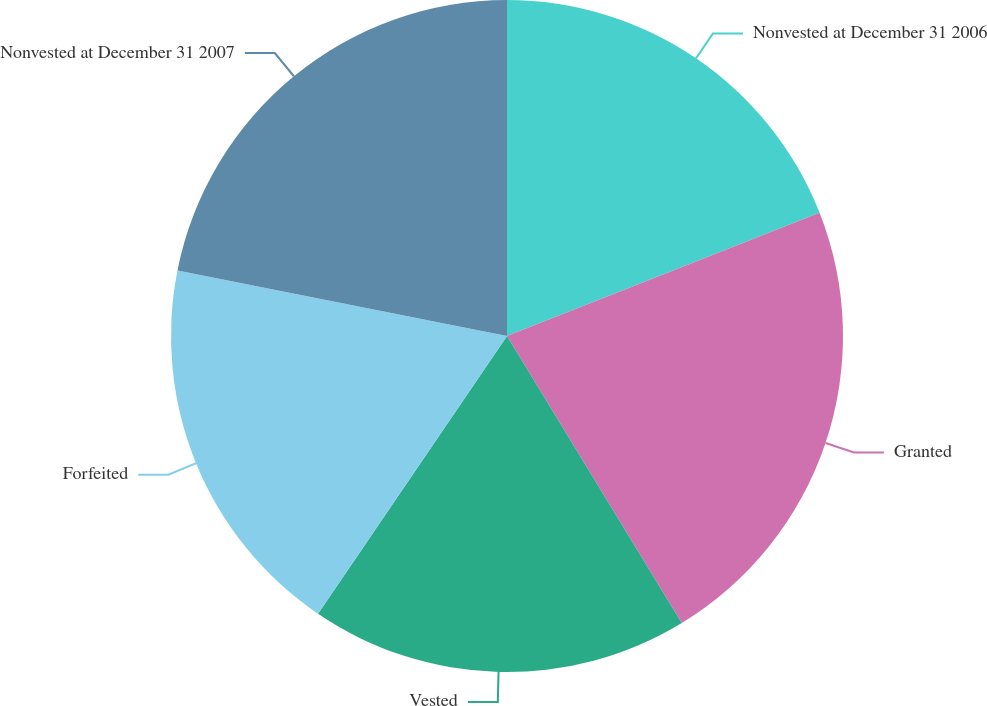<chart> <loc_0><loc_0><loc_500><loc_500><pie_chart><fcel>Nonvested at December 31 2006<fcel>Granted<fcel>Vested<fcel>Forfeited<fcel>Nonvested at December 31 2007<nl><fcel>19.02%<fcel>22.27%<fcel>18.21%<fcel>18.62%<fcel>21.87%<nl></chart> 